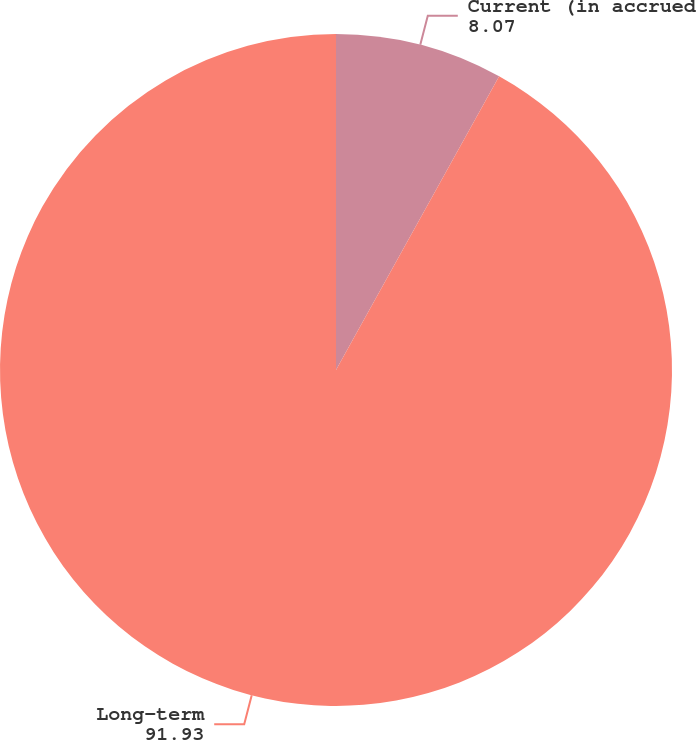Convert chart to OTSL. <chart><loc_0><loc_0><loc_500><loc_500><pie_chart><fcel>Current (in accrued<fcel>Long-term<nl><fcel>8.07%<fcel>91.93%<nl></chart> 